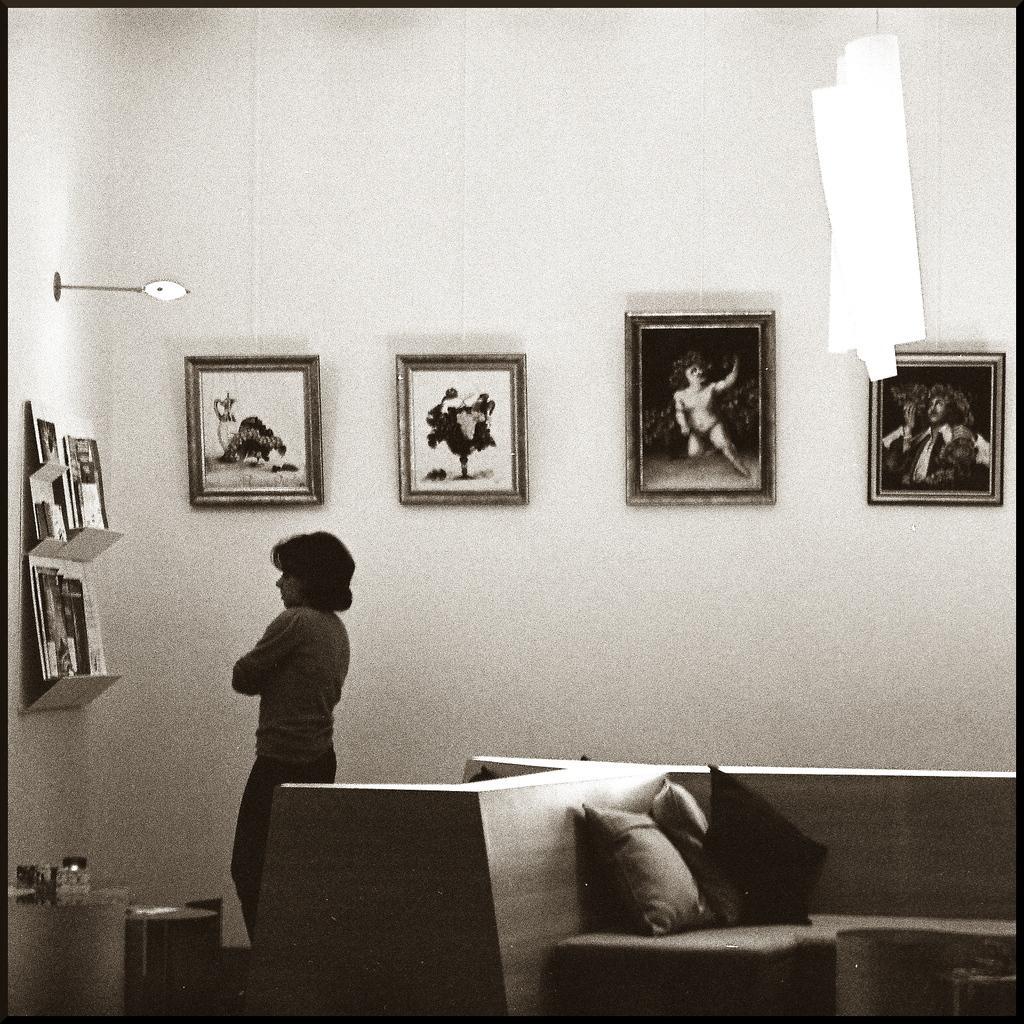How would you summarize this image in a sentence or two? In the image there is sofa in the front with pillows on it and on left side there is a woman standing and looking at the books on the shelves, on the back wall there are photographs on it, this is a black and white picture,on the left side wall there is light. 